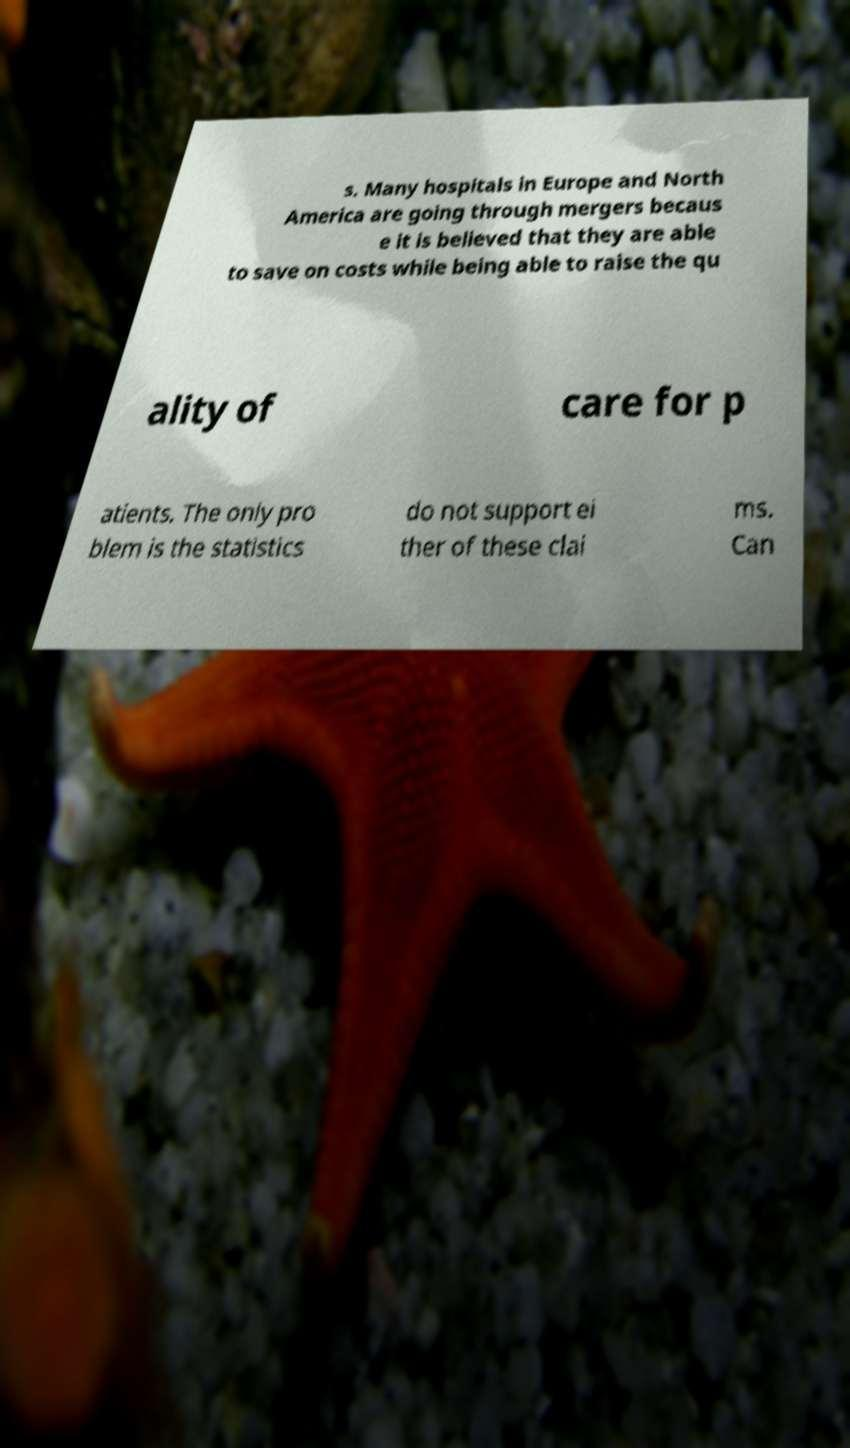Please identify and transcribe the text found in this image. s. Many hospitals in Europe and North America are going through mergers becaus e it is believed that they are able to save on costs while being able to raise the qu ality of care for p atients. The only pro blem is the statistics do not support ei ther of these clai ms. Can 